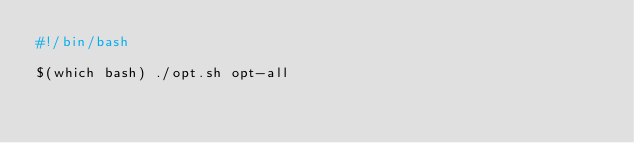Convert code to text. <code><loc_0><loc_0><loc_500><loc_500><_Bash_>#!/bin/bash

$(which bash) ./opt.sh opt-all
</code> 